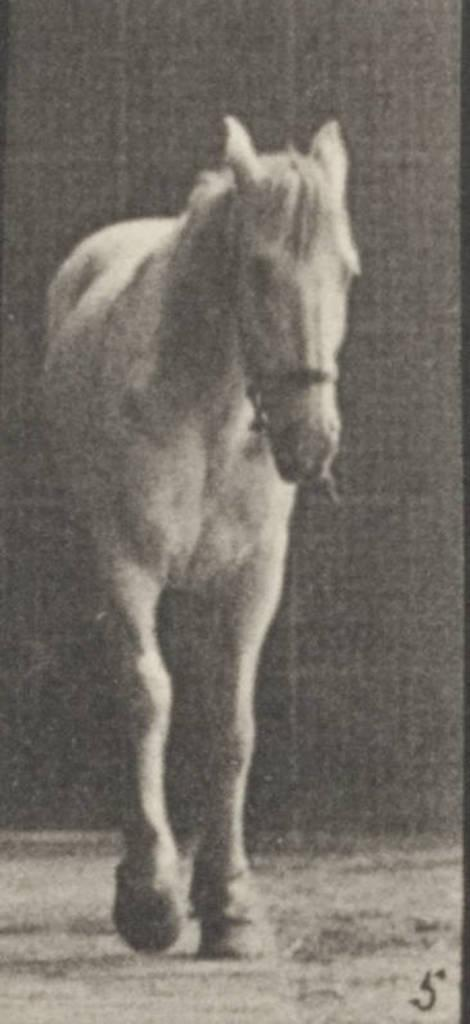What is the main subject of the image? The main subject of the image is a black and white picture of a horse. Where is the picture of the horse located in the image? The picture of the horse is on the ground. Can you tell me how many times the horse jumps in the image? There is no horse present in the image, only a picture of a horse. Additionally, the horse in the picture is not performing any action like jumping. 